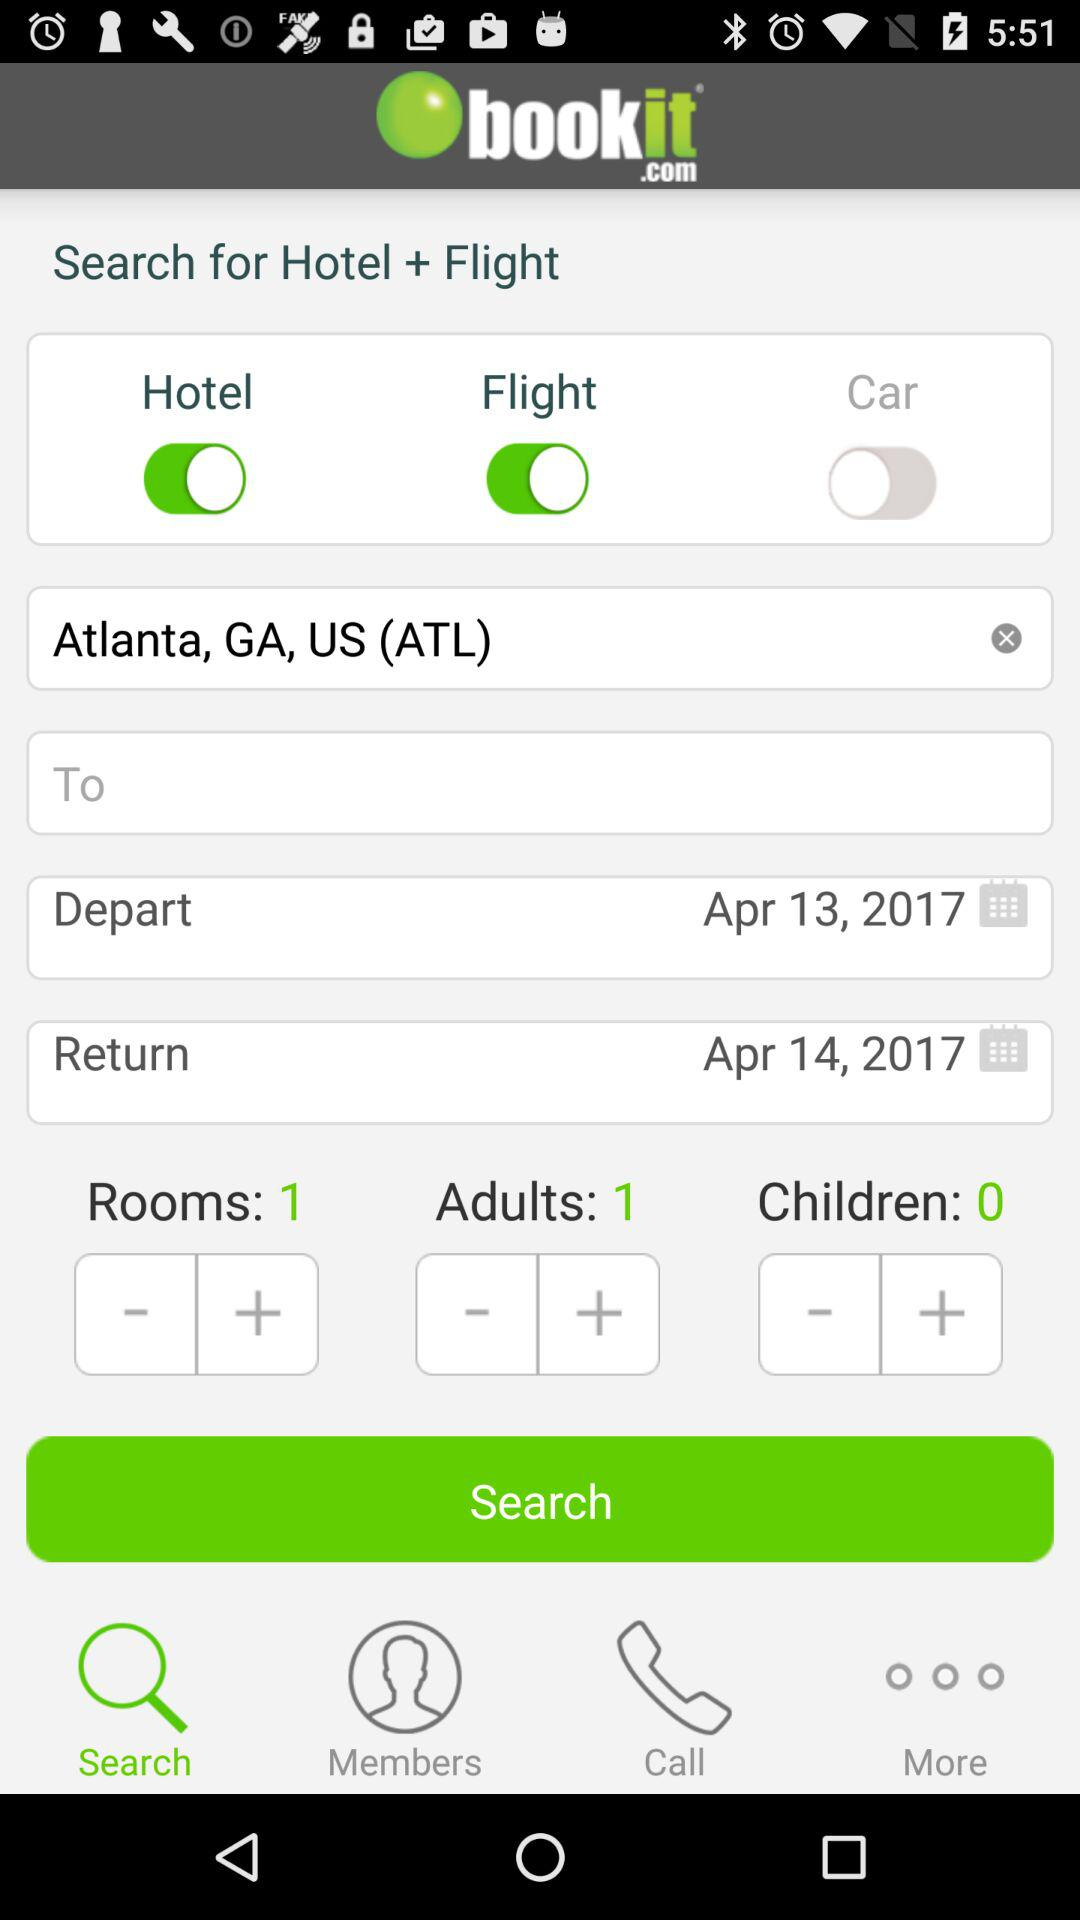What's the return date? The return date is April 14, 2017. 